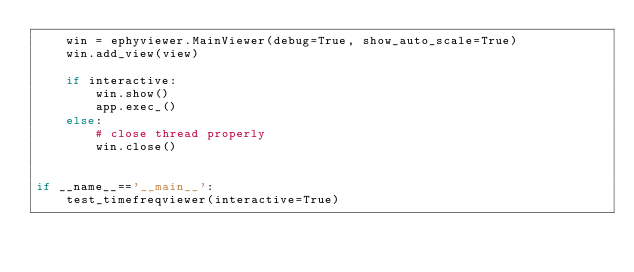<code> <loc_0><loc_0><loc_500><loc_500><_Python_>    win = ephyviewer.MainViewer(debug=True, show_auto_scale=True)
    win.add_view(view)

    if interactive:
        win.show()
        app.exec_()
    else:
        # close thread properly
        win.close()


if __name__=='__main__':
    test_timefreqviewer(interactive=True)
</code> 